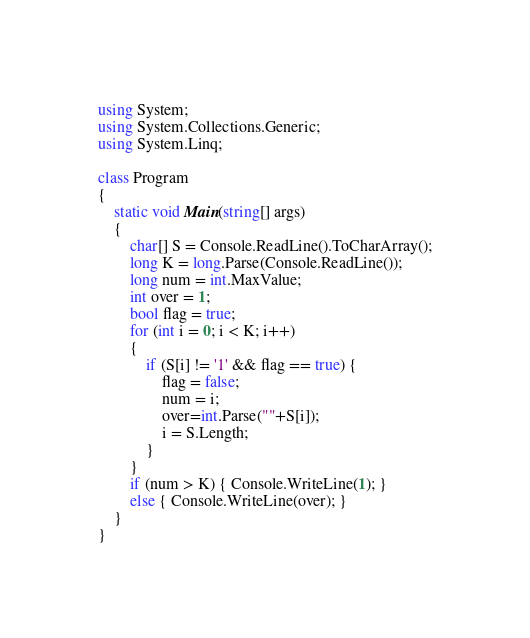Convert code to text. <code><loc_0><loc_0><loc_500><loc_500><_C#_>using System;
using System.Collections.Generic;
using System.Linq;

class Program
{
    static void Main(string[] args)
    {
        char[] S = Console.ReadLine().ToCharArray();
        long K = long.Parse(Console.ReadLine());
        long num = int.MaxValue;
        int over = 1;
        bool flag = true;
        for (int i = 0; i < K; i++)
        {
            if (S[i] != '1' && flag == true) {
                flag = false;
                num = i;
                over=int.Parse(""+S[i]);
                i = S.Length;
            }
        }
        if (num > K) { Console.WriteLine(1); }
        else { Console.WriteLine(over); }
    }
}
</code> 